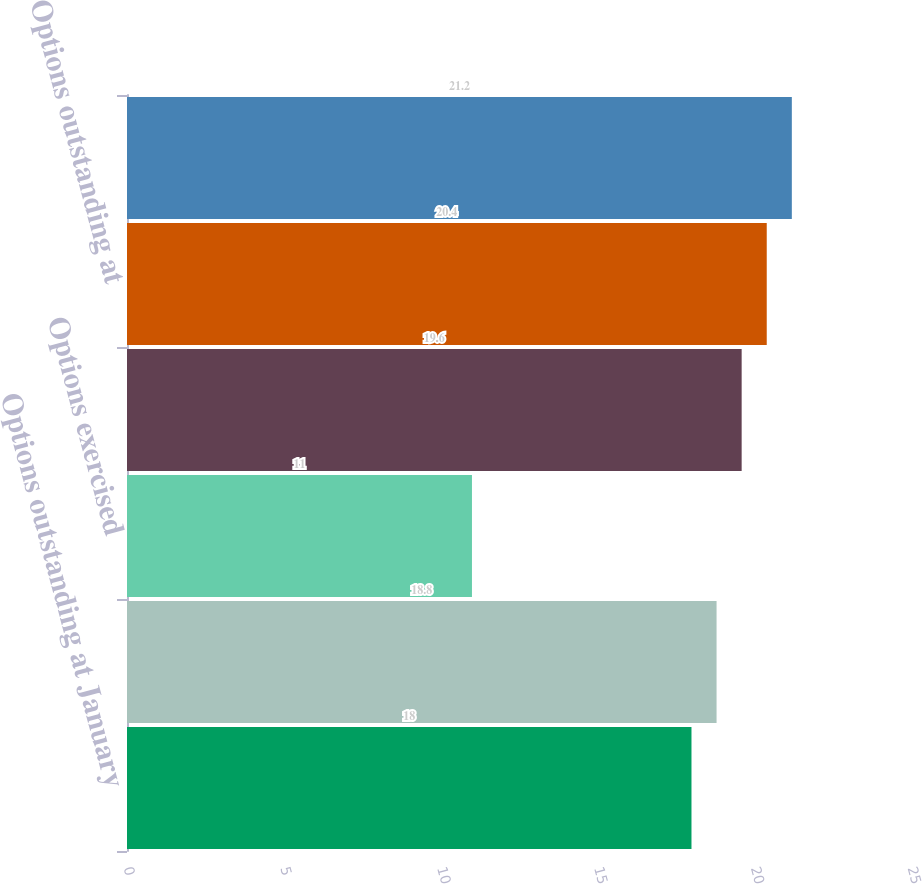Convert chart. <chart><loc_0><loc_0><loc_500><loc_500><bar_chart><fcel>Options outstanding at January<fcel>Options granted<fcel>Options exercised<fcel>Options terminated canceled or<fcel>Options outstanding at<fcel>Options exercisable at<nl><fcel>18<fcel>18.8<fcel>11<fcel>19.6<fcel>20.4<fcel>21.2<nl></chart> 